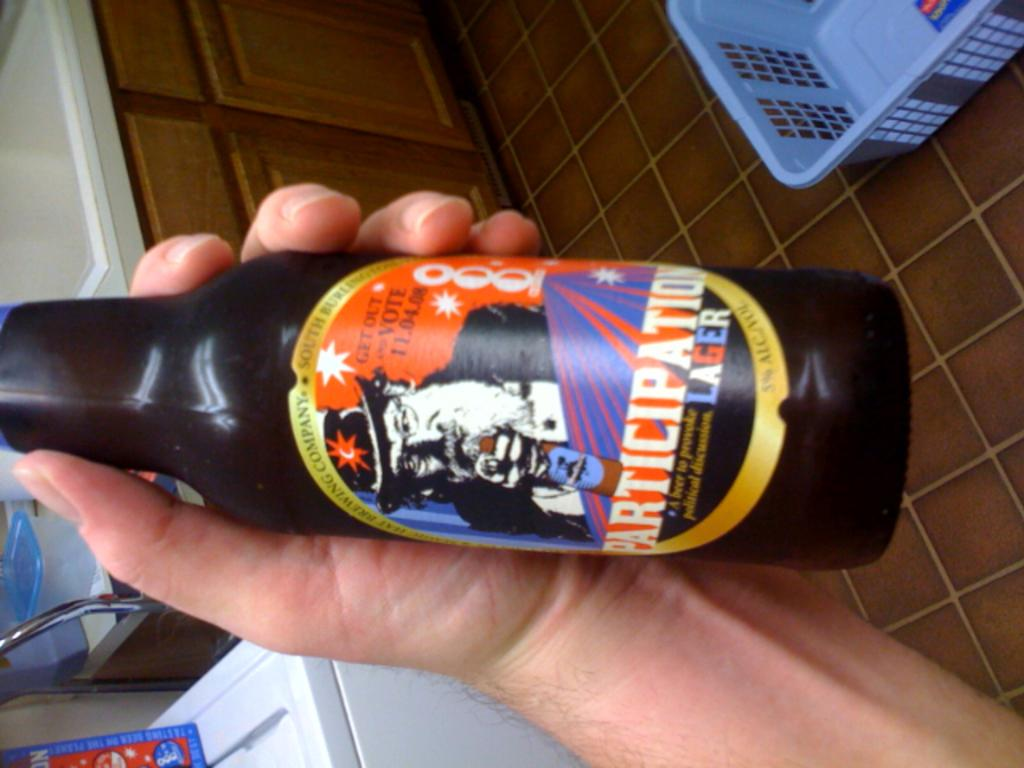<image>
Relay a brief, clear account of the picture shown. A picture is rotated 90 degrees left showing a man's hand holding a bottle of Participation Lager. 